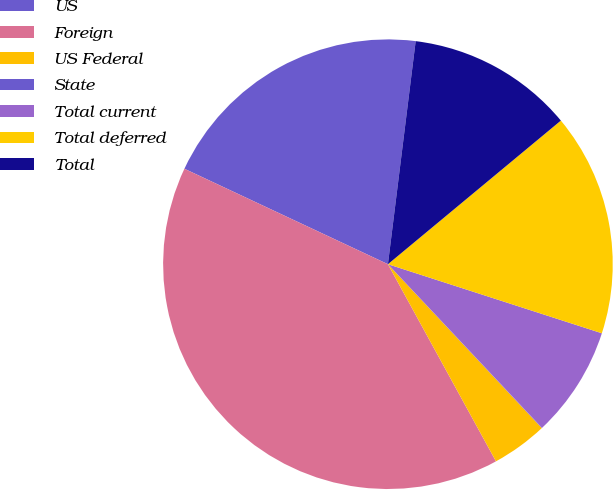<chart> <loc_0><loc_0><loc_500><loc_500><pie_chart><fcel>US<fcel>Foreign<fcel>US Federal<fcel>State<fcel>Total current<fcel>Total deferred<fcel>Total<nl><fcel>19.99%<fcel>39.96%<fcel>4.02%<fcel>0.02%<fcel>8.01%<fcel>16.0%<fcel>12.0%<nl></chart> 